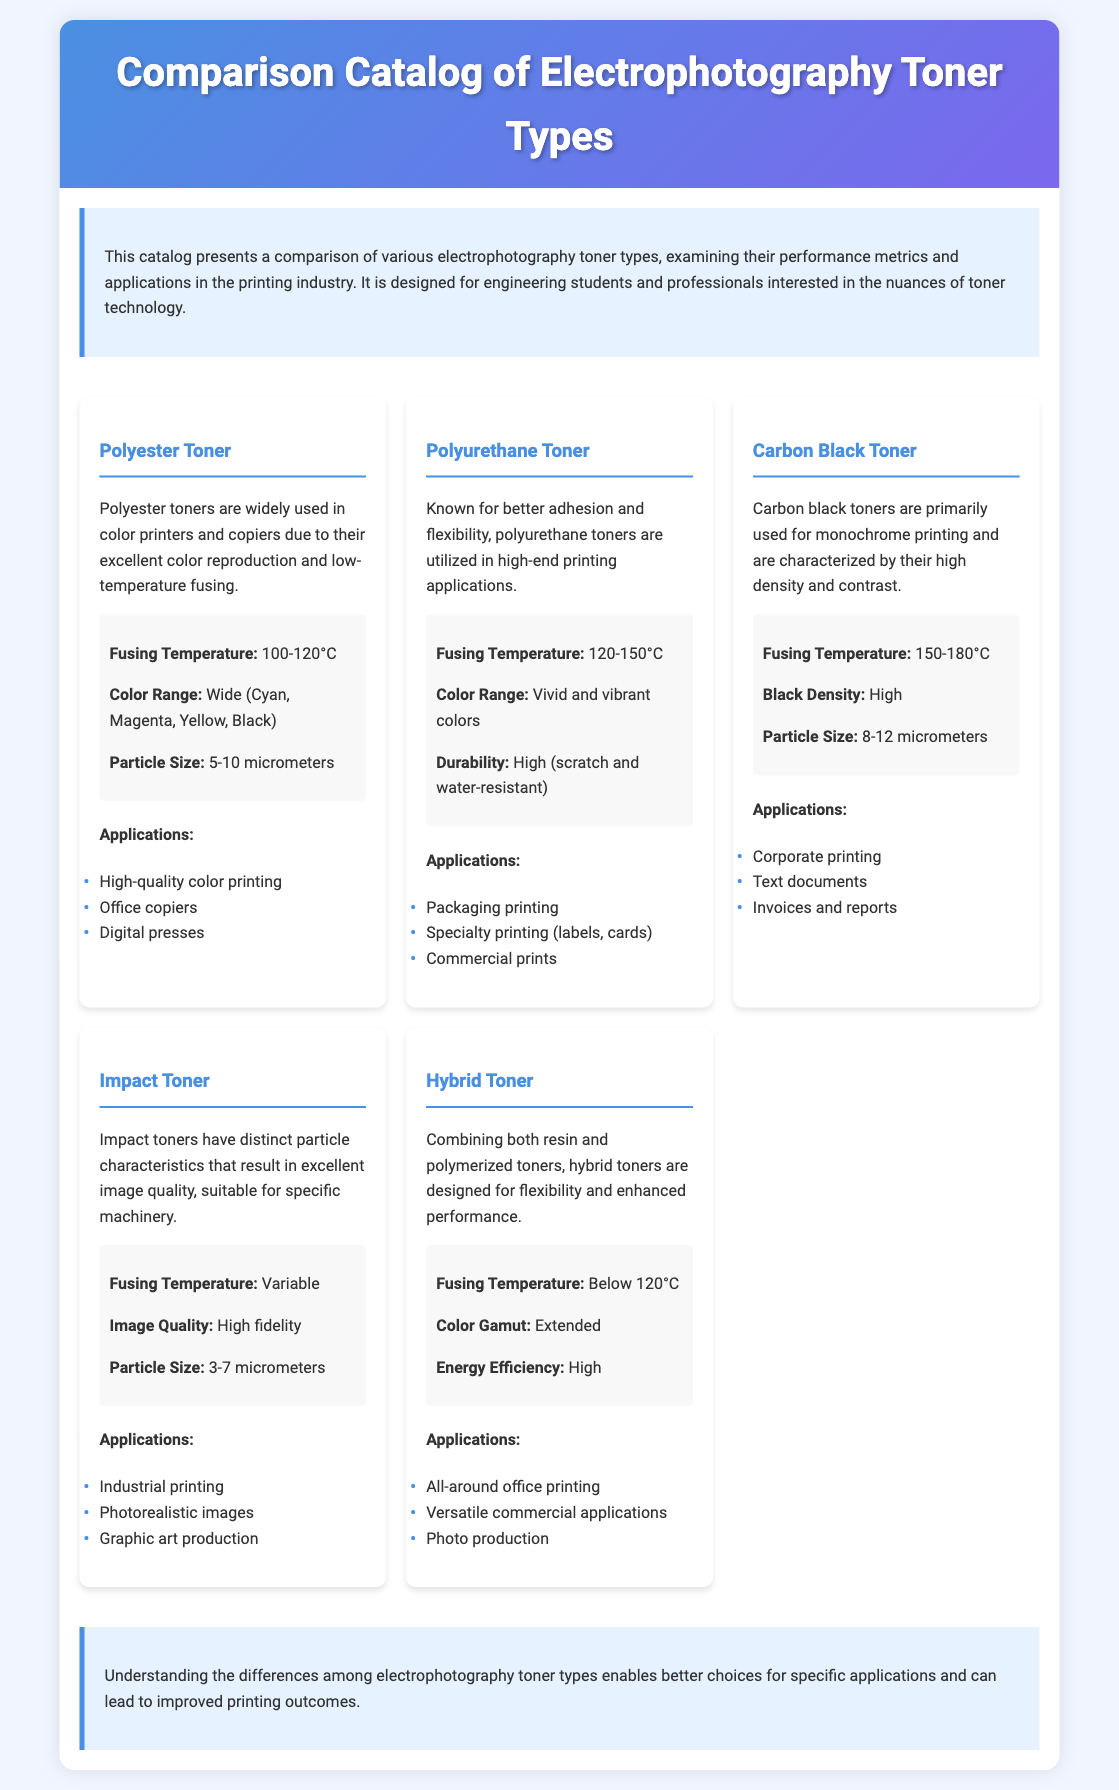What is the fusing temperature for Polyester Toner? The fusing temperature is a specific performance metric listed for each toner type in the document. For Polyester Toner, it is 100-120°C.
Answer: 100-120°C What type of applications does Carbon Black Toner mainly serve? The applications mentioned for Carbon Black Toner are specific areas in printing. It is primarily used for monochrome printing.
Answer: Corporate printing Which toner type is characterized by its high density and contrast? This requires recalling specific characteristics mentioned in the document about different toners. Carbon Black Toner is noted for its high density and contrast.
Answer: Carbon Black Toner What is the particle size range for Impact Toner? The particle size is specified for each toner type, highlighting important details. Impact Toner has a particle size of 3-7 micrometers.
Answer: 3-7 micrometers Which toner has an extended color gamut? This question requires identifying the specific toner type that is noted for its color capabilities. Hybrid Toner is described as having an extended color gamut.
Answer: Hybrid Toner What is one of the key durability features of Polyurethane Toner? The document states specific durability features for various toners. Polyurethane Toner is noted for its high durability, being scratch and water-resistant.
Answer: High What common printing applications does Hybrid Toner support? This is about the applications listed for Hybrid Toner, which covers a range of uses. It supports versatile commercial applications.
Answer: Versatile commercial applications What is the color range offered by Polyester Toner? This question targets the specific color range mentioned in the toner descriptions. Polyester Toner offers a wide color range.
Answer: Wide What differentiates the fusing temperature of Polyurethane Toner from Carbon Black Toner? This requires comparing the fusing temperatures provided for both toner types. Polyurethane Toner has a fusing temperature of 120-150°C, while Carbon Black Toner has 150-180°C.
Answer: 120-150°C and 150-180°C 